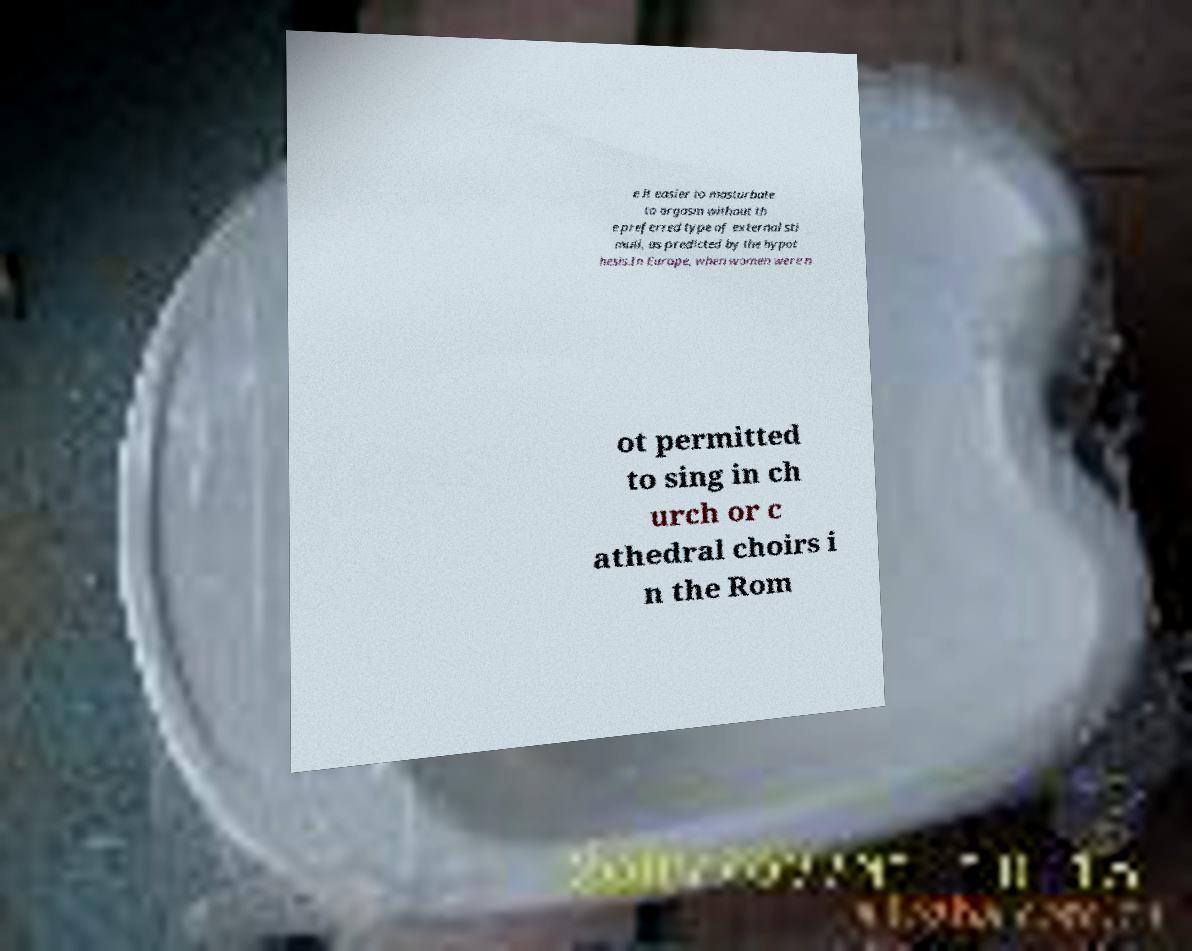There's text embedded in this image that I need extracted. Can you transcribe it verbatim? e it easier to masturbate to orgasm without th e preferred type of external sti muli, as predicted by the hypot hesis.In Europe, when women were n ot permitted to sing in ch urch or c athedral choirs i n the Rom 